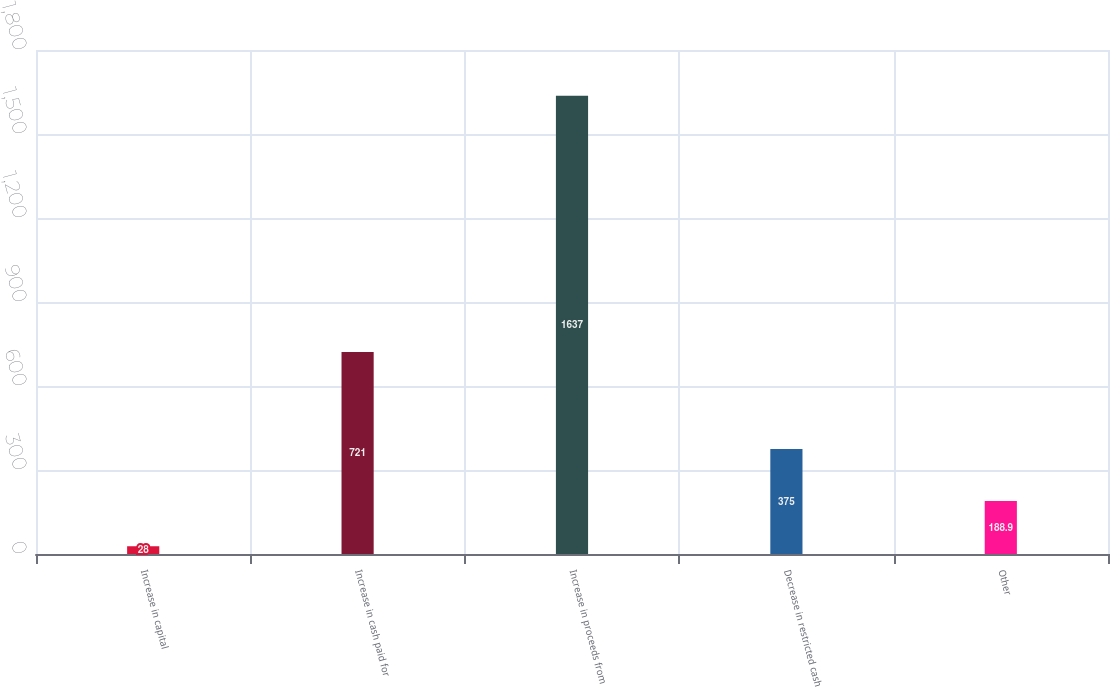<chart> <loc_0><loc_0><loc_500><loc_500><bar_chart><fcel>Increase in capital<fcel>Increase in cash paid for<fcel>Increase in proceeds from<fcel>Decrease in restricted cash<fcel>Other<nl><fcel>28<fcel>721<fcel>1637<fcel>375<fcel>188.9<nl></chart> 